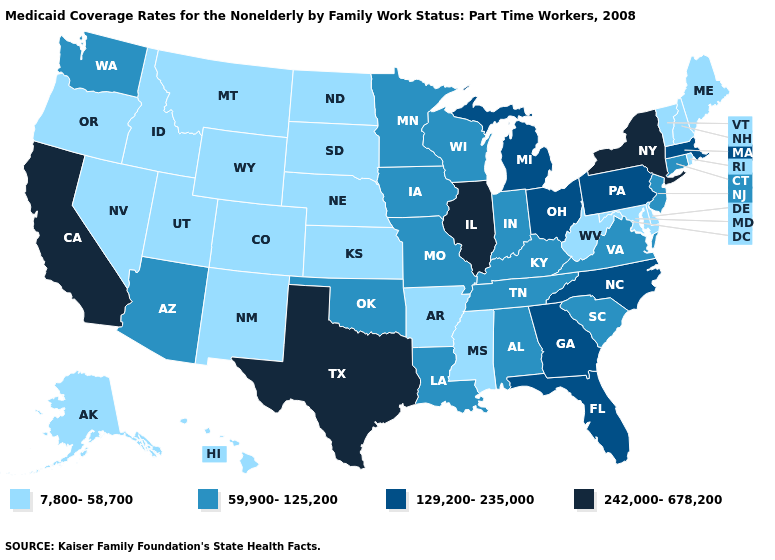What is the lowest value in the USA?
Keep it brief. 7,800-58,700. Is the legend a continuous bar?
Write a very short answer. No. Name the states that have a value in the range 129,200-235,000?
Write a very short answer. Florida, Georgia, Massachusetts, Michigan, North Carolina, Ohio, Pennsylvania. Which states hav the highest value in the MidWest?
Short answer required. Illinois. What is the lowest value in states that border North Carolina?
Quick response, please. 59,900-125,200. Does the first symbol in the legend represent the smallest category?
Write a very short answer. Yes. What is the lowest value in the USA?
Keep it brief. 7,800-58,700. Among the states that border Washington , which have the lowest value?
Answer briefly. Idaho, Oregon. Name the states that have a value in the range 59,900-125,200?
Keep it brief. Alabama, Arizona, Connecticut, Indiana, Iowa, Kentucky, Louisiana, Minnesota, Missouri, New Jersey, Oklahoma, South Carolina, Tennessee, Virginia, Washington, Wisconsin. What is the lowest value in the West?
Give a very brief answer. 7,800-58,700. Does California have the highest value in the West?
Short answer required. Yes. Which states hav the highest value in the MidWest?
Keep it brief. Illinois. Among the states that border Utah , does Arizona have the highest value?
Quick response, please. Yes. Among the states that border Alabama , which have the lowest value?
Keep it brief. Mississippi. Which states have the lowest value in the South?
Short answer required. Arkansas, Delaware, Maryland, Mississippi, West Virginia. 